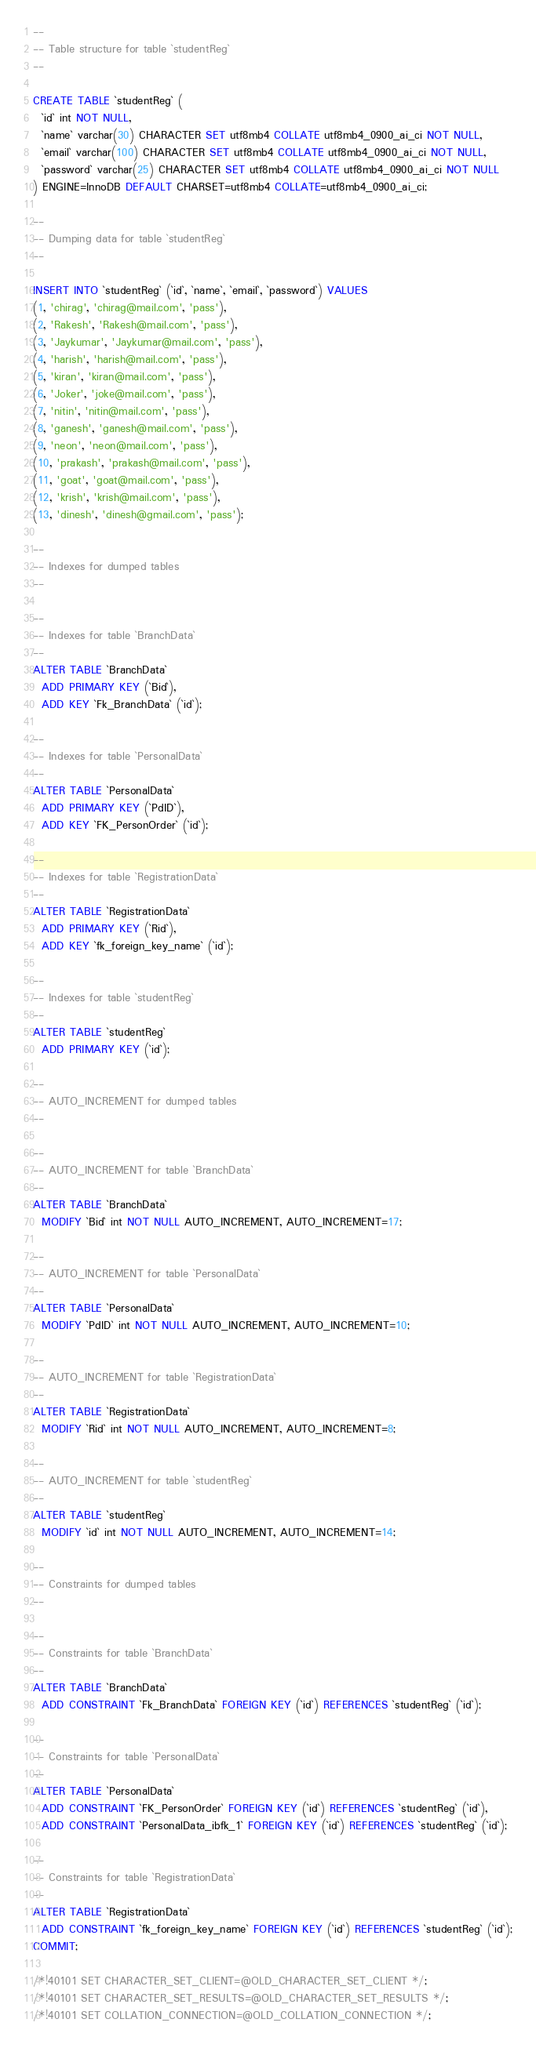Convert code to text. <code><loc_0><loc_0><loc_500><loc_500><_SQL_>
--
-- Table structure for table `studentReg`
--

CREATE TABLE `studentReg` (
  `id` int NOT NULL,
  `name` varchar(30) CHARACTER SET utf8mb4 COLLATE utf8mb4_0900_ai_ci NOT NULL,
  `email` varchar(100) CHARACTER SET utf8mb4 COLLATE utf8mb4_0900_ai_ci NOT NULL,
  `password` varchar(25) CHARACTER SET utf8mb4 COLLATE utf8mb4_0900_ai_ci NOT NULL
) ENGINE=InnoDB DEFAULT CHARSET=utf8mb4 COLLATE=utf8mb4_0900_ai_ci;

--
-- Dumping data for table `studentReg`
--

INSERT INTO `studentReg` (`id`, `name`, `email`, `password`) VALUES
(1, 'chirag', 'chirag@mail.com', 'pass'),
(2, 'Rakesh', 'Rakesh@mail.com', 'pass'),
(3, 'Jaykumar', 'Jaykumar@mail.com', 'pass'),
(4, 'harish', 'harish@mail.com', 'pass'),
(5, 'kiran', 'kiran@mail.com', 'pass'),
(6, 'Joker', 'joke@mail.com', 'pass'),
(7, 'nitin', 'nitin@mail.com', 'pass'),
(8, 'ganesh', 'ganesh@mail.com', 'pass'),
(9, 'neon', 'neon@mail.com', 'pass'),
(10, 'prakash', 'prakash@mail.com', 'pass'),
(11, 'goat', 'goat@mail.com', 'pass'),
(12, 'krish', 'krish@mail.com', 'pass'),
(13, 'dinesh', 'dinesh@gmail.com', 'pass');

--
-- Indexes for dumped tables
--

--
-- Indexes for table `BranchData`
--
ALTER TABLE `BranchData`
  ADD PRIMARY KEY (`Bid`),
  ADD KEY `Fk_BranchData` (`id`);

--
-- Indexes for table `PersonalData`
--
ALTER TABLE `PersonalData`
  ADD PRIMARY KEY (`PdID`),
  ADD KEY `FK_PersonOrder` (`id`);

--
-- Indexes for table `RegistrationData`
--
ALTER TABLE `RegistrationData`
  ADD PRIMARY KEY (`Rid`),
  ADD KEY `fk_foreign_key_name` (`id`);

--
-- Indexes for table `studentReg`
--
ALTER TABLE `studentReg`
  ADD PRIMARY KEY (`id`);

--
-- AUTO_INCREMENT for dumped tables
--

--
-- AUTO_INCREMENT for table `BranchData`
--
ALTER TABLE `BranchData`
  MODIFY `Bid` int NOT NULL AUTO_INCREMENT, AUTO_INCREMENT=17;

--
-- AUTO_INCREMENT for table `PersonalData`
--
ALTER TABLE `PersonalData`
  MODIFY `PdID` int NOT NULL AUTO_INCREMENT, AUTO_INCREMENT=10;

--
-- AUTO_INCREMENT for table `RegistrationData`
--
ALTER TABLE `RegistrationData`
  MODIFY `Rid` int NOT NULL AUTO_INCREMENT, AUTO_INCREMENT=8;

--
-- AUTO_INCREMENT for table `studentReg`
--
ALTER TABLE `studentReg`
  MODIFY `id` int NOT NULL AUTO_INCREMENT, AUTO_INCREMENT=14;

--
-- Constraints for dumped tables
--

--
-- Constraints for table `BranchData`
--
ALTER TABLE `BranchData`
  ADD CONSTRAINT `Fk_BranchData` FOREIGN KEY (`id`) REFERENCES `studentReg` (`id`);

--
-- Constraints for table `PersonalData`
--
ALTER TABLE `PersonalData`
  ADD CONSTRAINT `FK_PersonOrder` FOREIGN KEY (`id`) REFERENCES `studentReg` (`id`),
  ADD CONSTRAINT `PersonalData_ibfk_1` FOREIGN KEY (`id`) REFERENCES `studentReg` (`id`);

--
-- Constraints for table `RegistrationData`
--
ALTER TABLE `RegistrationData`
  ADD CONSTRAINT `fk_foreign_key_name` FOREIGN KEY (`id`) REFERENCES `studentReg` (`id`);
COMMIT;

/*!40101 SET CHARACTER_SET_CLIENT=@OLD_CHARACTER_SET_CLIENT */;
/*!40101 SET CHARACTER_SET_RESULTS=@OLD_CHARACTER_SET_RESULTS */;
/*!40101 SET COLLATION_CONNECTION=@OLD_COLLATION_CONNECTION */;
</code> 